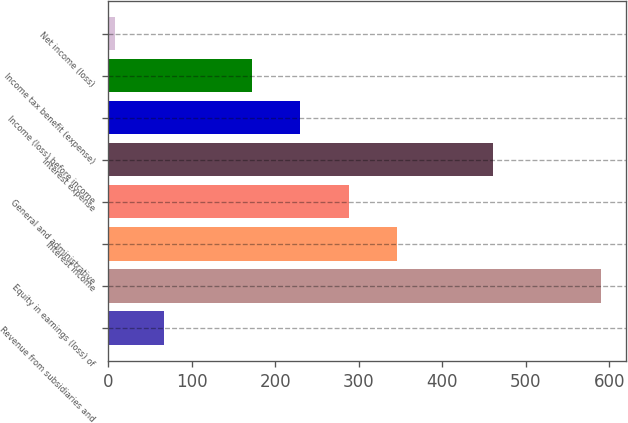Convert chart to OTSL. <chart><loc_0><loc_0><loc_500><loc_500><bar_chart><fcel>Revenue from subsidiaries and<fcel>Equity in earnings (loss) of<fcel>Interest income<fcel>General and administrative<fcel>Interest expense<fcel>Income (loss) before income<fcel>Income tax benefit (expense)<fcel>Net income (loss)<nl><fcel>67.1<fcel>590<fcel>346.3<fcel>288.2<fcel>461<fcel>230.1<fcel>172<fcel>9<nl></chart> 